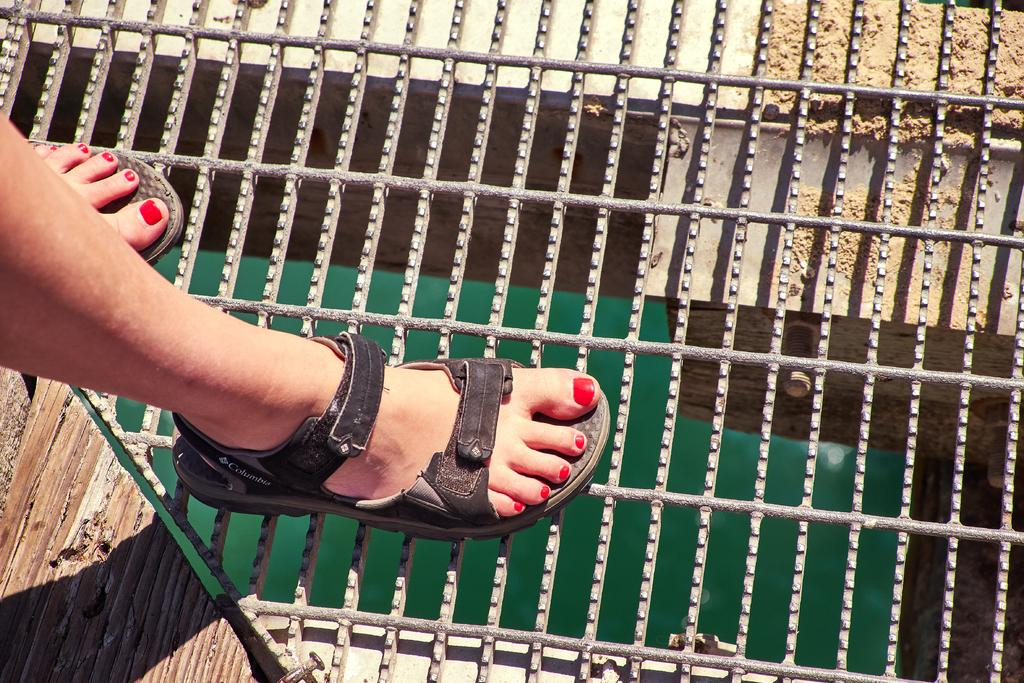What is the person in the image doing? The person is standing on iron rods in the image. What can be seen on the left side of the image? There is a wooden surface on the left side of the image. What is the color of the object under the iron rods? The object under the iron rods is green in color. What decision does the rat make in the image? There is no rat present in the image, so no decision can be made by a rat. 